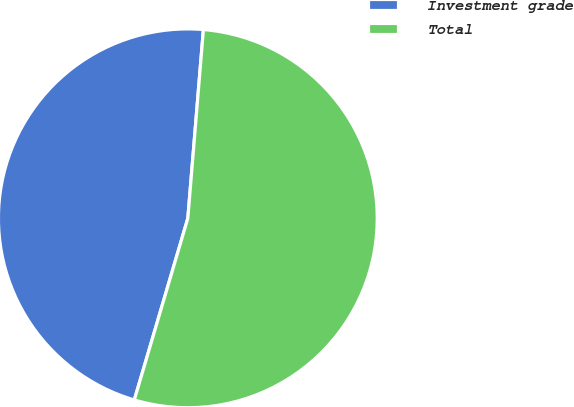Convert chart. <chart><loc_0><loc_0><loc_500><loc_500><pie_chart><fcel>Investment grade<fcel>Total<nl><fcel>46.75%<fcel>53.25%<nl></chart> 